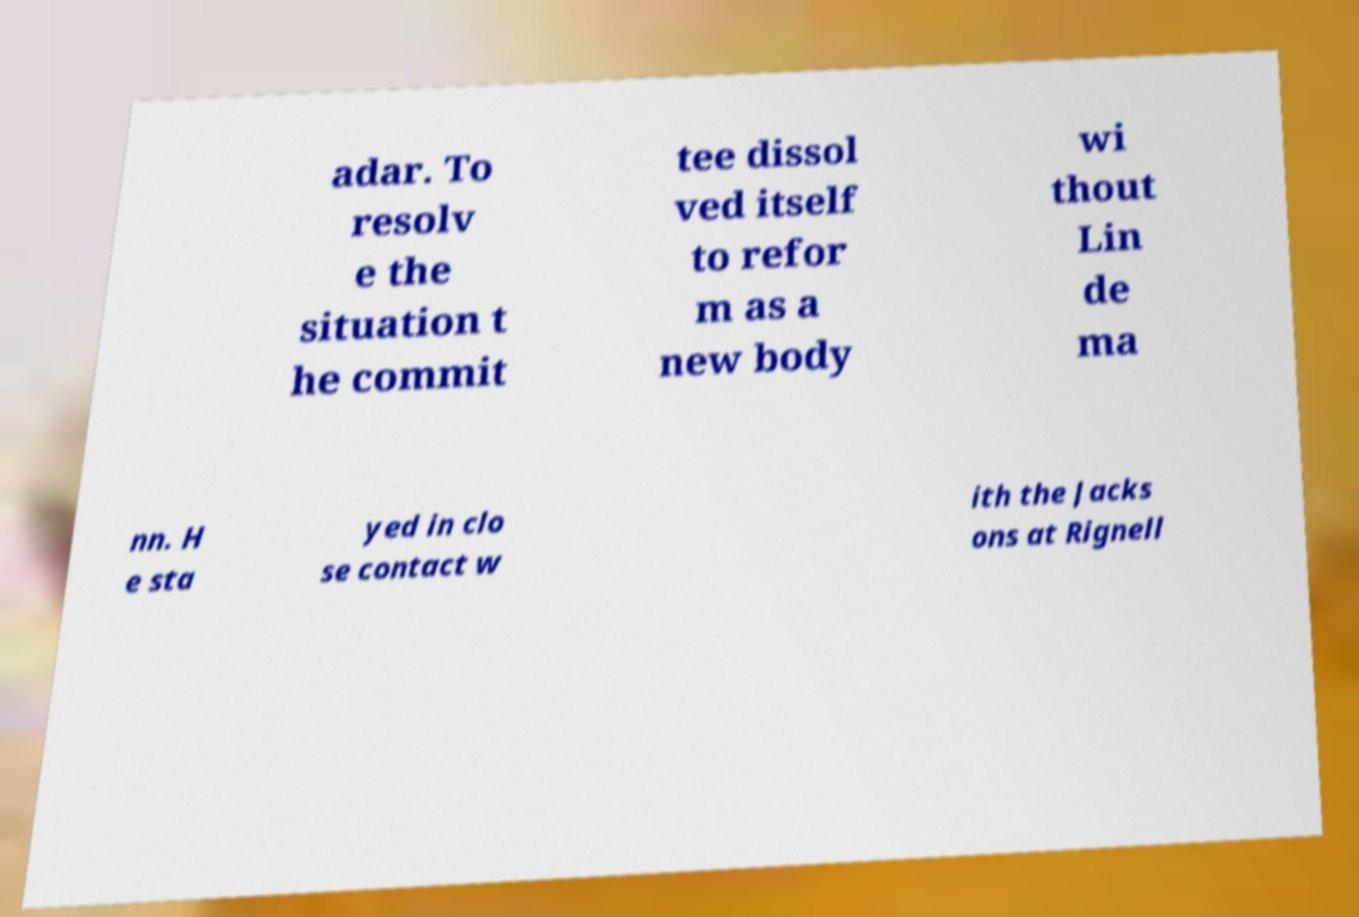I need the written content from this picture converted into text. Can you do that? adar. To resolv e the situation t he commit tee dissol ved itself to refor m as a new body wi thout Lin de ma nn. H e sta yed in clo se contact w ith the Jacks ons at Rignell 